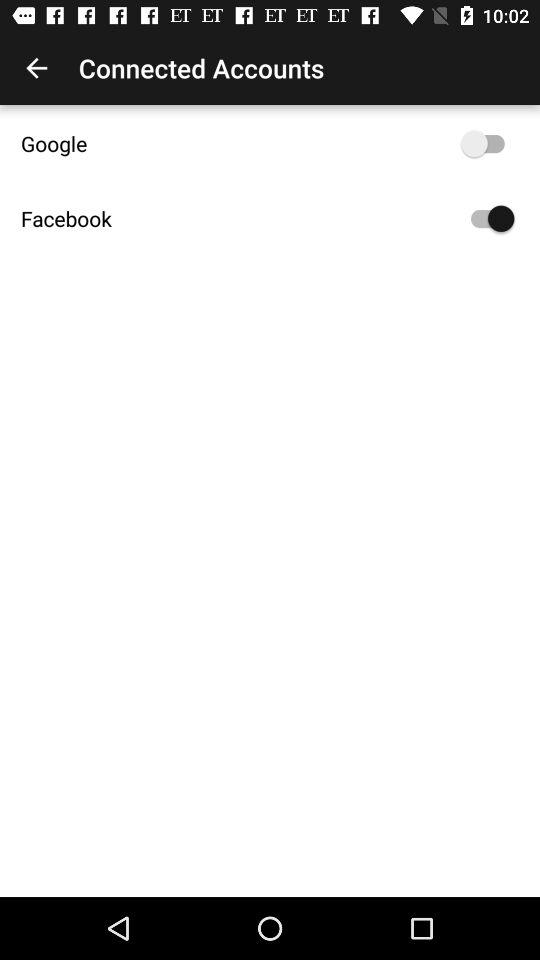How many accounts are connected?
Answer the question using a single word or phrase. 2 